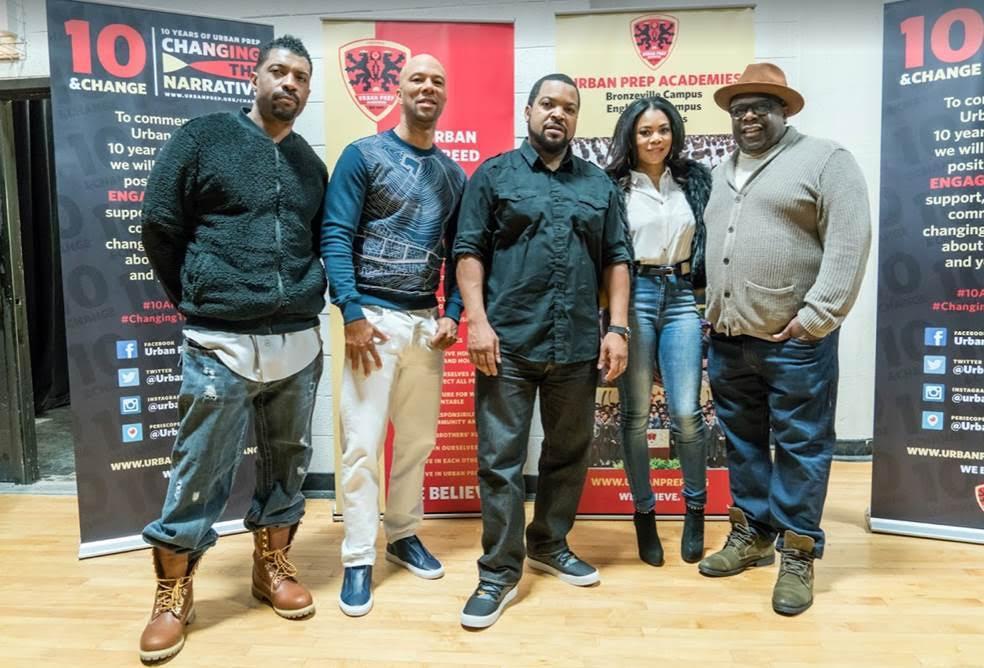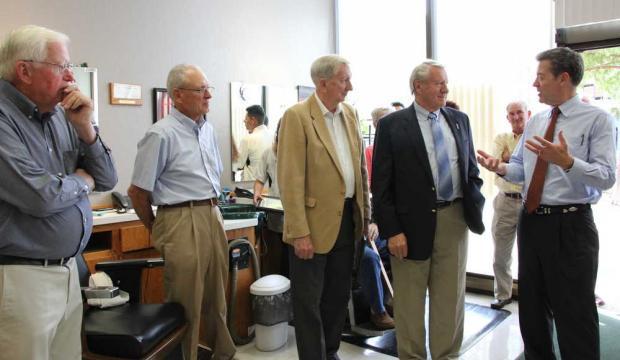The first image is the image on the left, the second image is the image on the right. Assess this claim about the two images: "In one of the images, a man stands alone with no one else present.". Correct or not? Answer yes or no. No. 